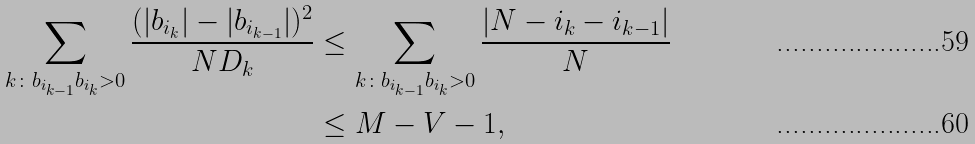Convert formula to latex. <formula><loc_0><loc_0><loc_500><loc_500>\sum _ { k \colon b _ { i _ { k - 1 } } b _ { i _ { k } } > 0 } \frac { ( | b _ { i _ { k } } | - | b _ { i _ { k - 1 } } | ) ^ { 2 } } { N D _ { k } } & \leq \sum _ { k \colon b _ { i _ { k - 1 } } b _ { i _ { k } } > 0 } \frac { | N - i _ { k } - i _ { k - 1 } | } { N } \\ & \leq M - V - 1 ,</formula> 